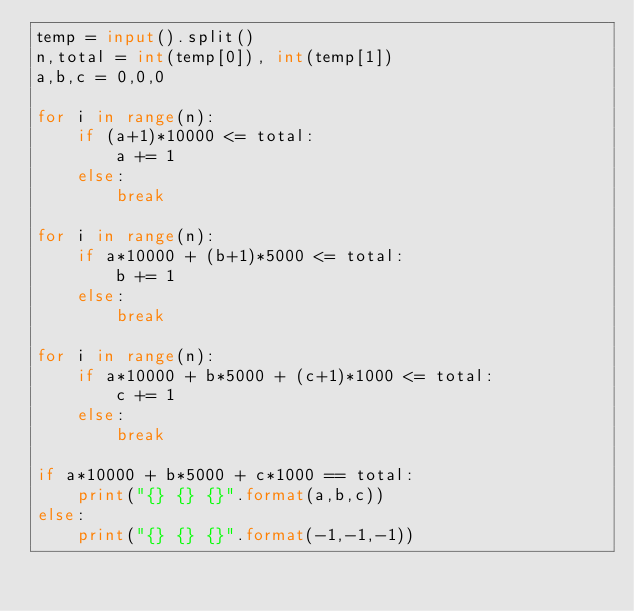<code> <loc_0><loc_0><loc_500><loc_500><_Python_>temp = input().split()
n,total = int(temp[0]), int(temp[1])
a,b,c = 0,0,0

for i in range(n):
    if (a+1)*10000 <= total:
        a += 1
    else:
        break
    
for i in range(n):
    if a*10000 + (b+1)*5000 <= total:
        b += 1
    else:
        break

for i in range(n):
    if a*10000 + b*5000 + (c+1)*1000 <= total:
        c += 1
    else:
        break
    
if a*10000 + b*5000 + c*1000 == total:
    print("{} {} {}".format(a,b,c))
else:
    print("{} {} {}".format(-1,-1,-1))</code> 